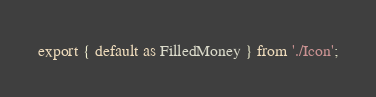Convert code to text. <code><loc_0><loc_0><loc_500><loc_500><_TypeScript_>export { default as FilledMoney } from './Icon';
</code> 